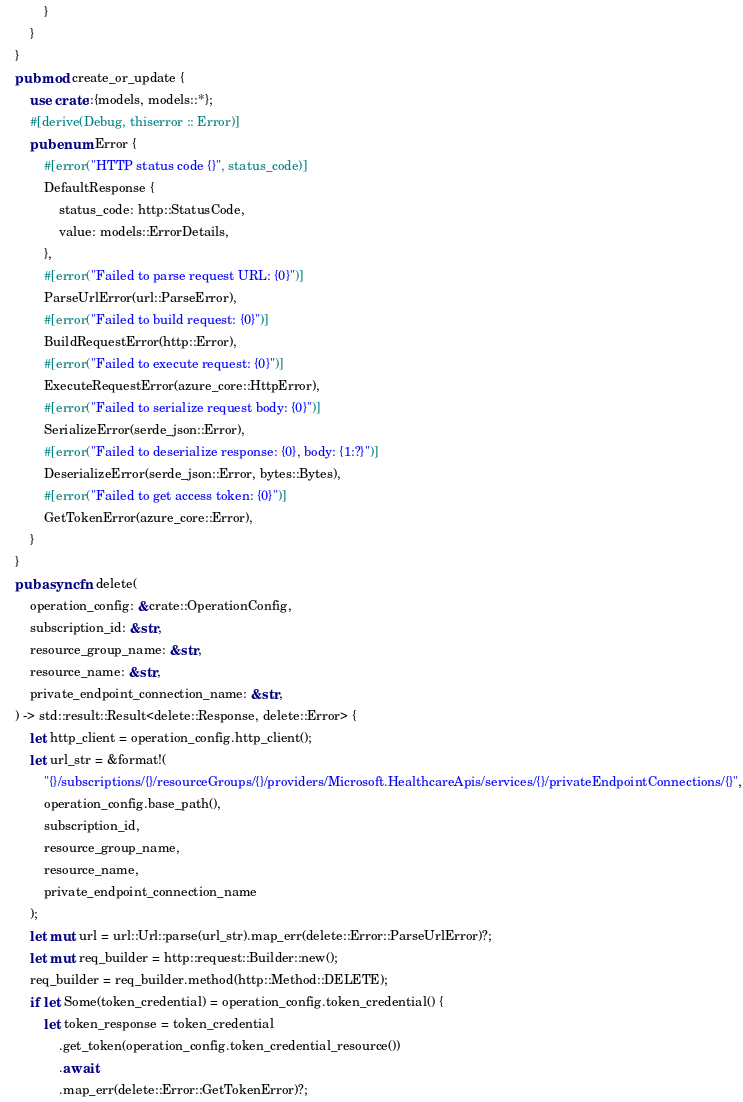Convert code to text. <code><loc_0><loc_0><loc_500><loc_500><_Rust_>            }
        }
    }
    pub mod create_or_update {
        use crate::{models, models::*};
        #[derive(Debug, thiserror :: Error)]
        pub enum Error {
            #[error("HTTP status code {}", status_code)]
            DefaultResponse {
                status_code: http::StatusCode,
                value: models::ErrorDetails,
            },
            #[error("Failed to parse request URL: {0}")]
            ParseUrlError(url::ParseError),
            #[error("Failed to build request: {0}")]
            BuildRequestError(http::Error),
            #[error("Failed to execute request: {0}")]
            ExecuteRequestError(azure_core::HttpError),
            #[error("Failed to serialize request body: {0}")]
            SerializeError(serde_json::Error),
            #[error("Failed to deserialize response: {0}, body: {1:?}")]
            DeserializeError(serde_json::Error, bytes::Bytes),
            #[error("Failed to get access token: {0}")]
            GetTokenError(azure_core::Error),
        }
    }
    pub async fn delete(
        operation_config: &crate::OperationConfig,
        subscription_id: &str,
        resource_group_name: &str,
        resource_name: &str,
        private_endpoint_connection_name: &str,
    ) -> std::result::Result<delete::Response, delete::Error> {
        let http_client = operation_config.http_client();
        let url_str = &format!(
            "{}/subscriptions/{}/resourceGroups/{}/providers/Microsoft.HealthcareApis/services/{}/privateEndpointConnections/{}",
            operation_config.base_path(),
            subscription_id,
            resource_group_name,
            resource_name,
            private_endpoint_connection_name
        );
        let mut url = url::Url::parse(url_str).map_err(delete::Error::ParseUrlError)?;
        let mut req_builder = http::request::Builder::new();
        req_builder = req_builder.method(http::Method::DELETE);
        if let Some(token_credential) = operation_config.token_credential() {
            let token_response = token_credential
                .get_token(operation_config.token_credential_resource())
                .await
                .map_err(delete::Error::GetTokenError)?;</code> 